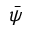<formula> <loc_0><loc_0><loc_500><loc_500>\bar { \psi }</formula> 